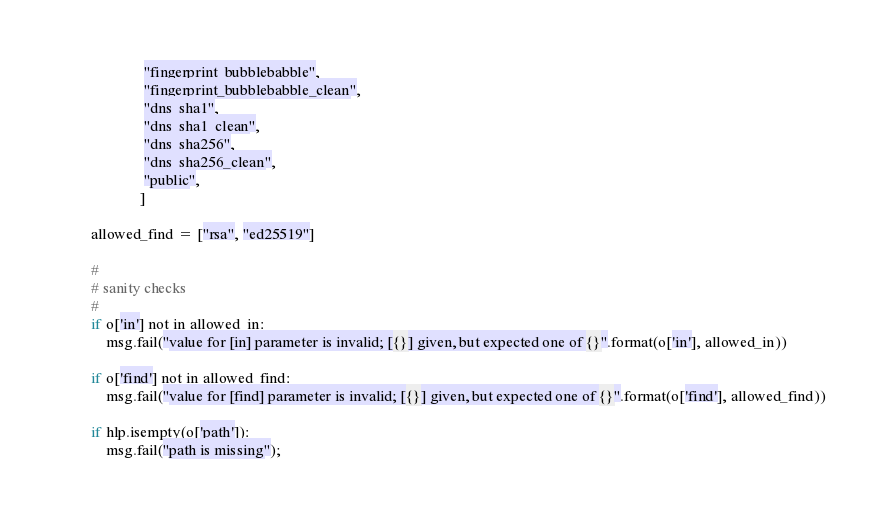<code> <loc_0><loc_0><loc_500><loc_500><_Python_>                      "fingerprint_bubblebabble",
                      "fingerprint_bubblebabble_clean",
                      "dns_sha1",
                      "dns_sha1_clean",
                      "dns_sha256",
                      "dns_sha256_clean",
                      "public",
                     ]

        allowed_find = ["rsa", "ed25519"]

        #
        # sanity checks
        #
        if o['in'] not in allowed_in:
            msg.fail("value for [in] parameter is invalid; [{}] given, but expected one of {}".format(o['in'], allowed_in))

        if o['find'] not in allowed_find:
            msg.fail("value for [find] parameter is invalid; [{}] given, but expected one of {}".format(o['find'], allowed_find))

        if hlp.isempty(o['path']):
            msg.fail("path is missing");
</code> 